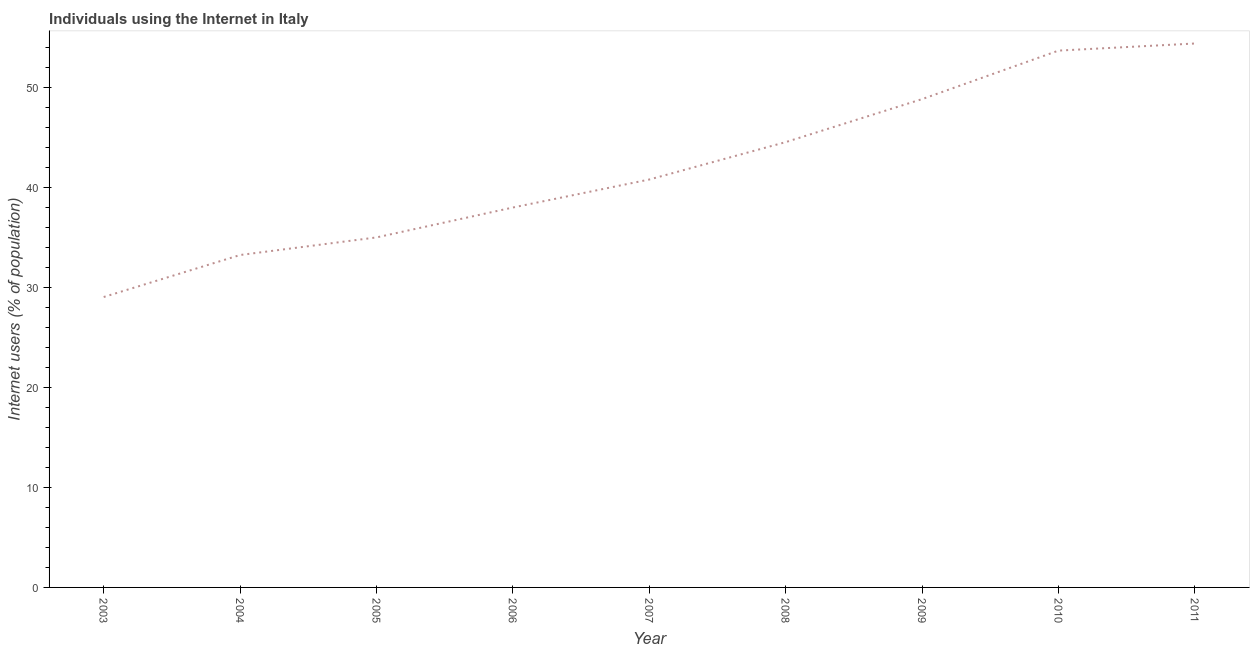What is the number of internet users in 2007?
Ensure brevity in your answer.  40.79. Across all years, what is the maximum number of internet users?
Make the answer very short. 54.39. Across all years, what is the minimum number of internet users?
Provide a succinct answer. 29.04. In which year was the number of internet users maximum?
Make the answer very short. 2011. What is the sum of the number of internet users?
Give a very brief answer. 377.49. What is the difference between the number of internet users in 2003 and 2011?
Offer a very short reply. -25.35. What is the average number of internet users per year?
Keep it short and to the point. 41.94. What is the median number of internet users?
Your answer should be compact. 40.79. In how many years, is the number of internet users greater than 30 %?
Make the answer very short. 8. What is the ratio of the number of internet users in 2006 to that in 2010?
Offer a very short reply. 0.71. Is the number of internet users in 2003 less than that in 2006?
Your response must be concise. Yes. What is the difference between the highest and the second highest number of internet users?
Give a very brief answer. 0.71. Is the sum of the number of internet users in 2009 and 2011 greater than the maximum number of internet users across all years?
Provide a succinct answer. Yes. What is the difference between the highest and the lowest number of internet users?
Make the answer very short. 25.35. Are the values on the major ticks of Y-axis written in scientific E-notation?
Provide a succinct answer. No. Does the graph contain grids?
Keep it short and to the point. No. What is the title of the graph?
Your response must be concise. Individuals using the Internet in Italy. What is the label or title of the Y-axis?
Your response must be concise. Internet users (% of population). What is the Internet users (% of population) in 2003?
Make the answer very short. 29.04. What is the Internet users (% of population) of 2004?
Ensure brevity in your answer.  33.24. What is the Internet users (% of population) of 2005?
Make the answer very short. 35. What is the Internet users (% of population) in 2006?
Your response must be concise. 37.99. What is the Internet users (% of population) in 2007?
Your answer should be compact. 40.79. What is the Internet users (% of population) in 2008?
Offer a very short reply. 44.53. What is the Internet users (% of population) of 2009?
Offer a very short reply. 48.83. What is the Internet users (% of population) of 2010?
Your answer should be compact. 53.68. What is the Internet users (% of population) of 2011?
Keep it short and to the point. 54.39. What is the difference between the Internet users (% of population) in 2003 and 2004?
Ensure brevity in your answer.  -4.2. What is the difference between the Internet users (% of population) in 2003 and 2005?
Give a very brief answer. -5.96. What is the difference between the Internet users (% of population) in 2003 and 2006?
Offer a very short reply. -8.95. What is the difference between the Internet users (% of population) in 2003 and 2007?
Offer a very short reply. -11.75. What is the difference between the Internet users (% of population) in 2003 and 2008?
Provide a short and direct response. -15.49. What is the difference between the Internet users (% of population) in 2003 and 2009?
Your answer should be compact. -19.79. What is the difference between the Internet users (% of population) in 2003 and 2010?
Make the answer very short. -24.64. What is the difference between the Internet users (% of population) in 2003 and 2011?
Keep it short and to the point. -25.35. What is the difference between the Internet users (% of population) in 2004 and 2005?
Your answer should be compact. -1.76. What is the difference between the Internet users (% of population) in 2004 and 2006?
Your answer should be very brief. -4.75. What is the difference between the Internet users (% of population) in 2004 and 2007?
Your answer should be compact. -7.55. What is the difference between the Internet users (% of population) in 2004 and 2008?
Your response must be concise. -11.29. What is the difference between the Internet users (% of population) in 2004 and 2009?
Your answer should be very brief. -15.59. What is the difference between the Internet users (% of population) in 2004 and 2010?
Provide a succinct answer. -20.44. What is the difference between the Internet users (% of population) in 2004 and 2011?
Keep it short and to the point. -21.15. What is the difference between the Internet users (% of population) in 2005 and 2006?
Keep it short and to the point. -2.99. What is the difference between the Internet users (% of population) in 2005 and 2007?
Give a very brief answer. -5.79. What is the difference between the Internet users (% of population) in 2005 and 2008?
Your answer should be very brief. -9.53. What is the difference between the Internet users (% of population) in 2005 and 2009?
Keep it short and to the point. -13.83. What is the difference between the Internet users (% of population) in 2005 and 2010?
Provide a short and direct response. -18.68. What is the difference between the Internet users (% of population) in 2005 and 2011?
Provide a short and direct response. -19.39. What is the difference between the Internet users (% of population) in 2006 and 2007?
Your answer should be compact. -2.8. What is the difference between the Internet users (% of population) in 2006 and 2008?
Give a very brief answer. -6.54. What is the difference between the Internet users (% of population) in 2006 and 2009?
Offer a very short reply. -10.84. What is the difference between the Internet users (% of population) in 2006 and 2010?
Your answer should be very brief. -15.69. What is the difference between the Internet users (% of population) in 2006 and 2011?
Offer a terse response. -16.4. What is the difference between the Internet users (% of population) in 2007 and 2008?
Give a very brief answer. -3.74. What is the difference between the Internet users (% of population) in 2007 and 2009?
Keep it short and to the point. -8.04. What is the difference between the Internet users (% of population) in 2007 and 2010?
Offer a very short reply. -12.89. What is the difference between the Internet users (% of population) in 2008 and 2010?
Your answer should be compact. -9.15. What is the difference between the Internet users (% of population) in 2008 and 2011?
Make the answer very short. -9.86. What is the difference between the Internet users (% of population) in 2009 and 2010?
Your answer should be compact. -4.85. What is the difference between the Internet users (% of population) in 2009 and 2011?
Ensure brevity in your answer.  -5.56. What is the difference between the Internet users (% of population) in 2010 and 2011?
Your response must be concise. -0.71. What is the ratio of the Internet users (% of population) in 2003 to that in 2004?
Ensure brevity in your answer.  0.87. What is the ratio of the Internet users (% of population) in 2003 to that in 2005?
Provide a short and direct response. 0.83. What is the ratio of the Internet users (% of population) in 2003 to that in 2006?
Your answer should be very brief. 0.76. What is the ratio of the Internet users (% of population) in 2003 to that in 2007?
Your answer should be compact. 0.71. What is the ratio of the Internet users (% of population) in 2003 to that in 2008?
Offer a terse response. 0.65. What is the ratio of the Internet users (% of population) in 2003 to that in 2009?
Your answer should be compact. 0.59. What is the ratio of the Internet users (% of population) in 2003 to that in 2010?
Offer a terse response. 0.54. What is the ratio of the Internet users (% of population) in 2003 to that in 2011?
Offer a very short reply. 0.53. What is the ratio of the Internet users (% of population) in 2004 to that in 2005?
Offer a terse response. 0.95. What is the ratio of the Internet users (% of population) in 2004 to that in 2007?
Your answer should be compact. 0.81. What is the ratio of the Internet users (% of population) in 2004 to that in 2008?
Offer a very short reply. 0.75. What is the ratio of the Internet users (% of population) in 2004 to that in 2009?
Give a very brief answer. 0.68. What is the ratio of the Internet users (% of population) in 2004 to that in 2010?
Provide a short and direct response. 0.62. What is the ratio of the Internet users (% of population) in 2004 to that in 2011?
Give a very brief answer. 0.61. What is the ratio of the Internet users (% of population) in 2005 to that in 2006?
Provide a short and direct response. 0.92. What is the ratio of the Internet users (% of population) in 2005 to that in 2007?
Offer a terse response. 0.86. What is the ratio of the Internet users (% of population) in 2005 to that in 2008?
Your answer should be compact. 0.79. What is the ratio of the Internet users (% of population) in 2005 to that in 2009?
Your answer should be very brief. 0.72. What is the ratio of the Internet users (% of population) in 2005 to that in 2010?
Make the answer very short. 0.65. What is the ratio of the Internet users (% of population) in 2005 to that in 2011?
Your answer should be compact. 0.64. What is the ratio of the Internet users (% of population) in 2006 to that in 2008?
Ensure brevity in your answer.  0.85. What is the ratio of the Internet users (% of population) in 2006 to that in 2009?
Your answer should be compact. 0.78. What is the ratio of the Internet users (% of population) in 2006 to that in 2010?
Offer a very short reply. 0.71. What is the ratio of the Internet users (% of population) in 2006 to that in 2011?
Make the answer very short. 0.7. What is the ratio of the Internet users (% of population) in 2007 to that in 2008?
Keep it short and to the point. 0.92. What is the ratio of the Internet users (% of population) in 2007 to that in 2009?
Provide a short and direct response. 0.83. What is the ratio of the Internet users (% of population) in 2007 to that in 2010?
Ensure brevity in your answer.  0.76. What is the ratio of the Internet users (% of population) in 2008 to that in 2009?
Provide a succinct answer. 0.91. What is the ratio of the Internet users (% of population) in 2008 to that in 2010?
Give a very brief answer. 0.83. What is the ratio of the Internet users (% of population) in 2008 to that in 2011?
Provide a short and direct response. 0.82. What is the ratio of the Internet users (% of population) in 2009 to that in 2010?
Make the answer very short. 0.91. What is the ratio of the Internet users (% of population) in 2009 to that in 2011?
Offer a very short reply. 0.9. What is the ratio of the Internet users (% of population) in 2010 to that in 2011?
Your answer should be very brief. 0.99. 